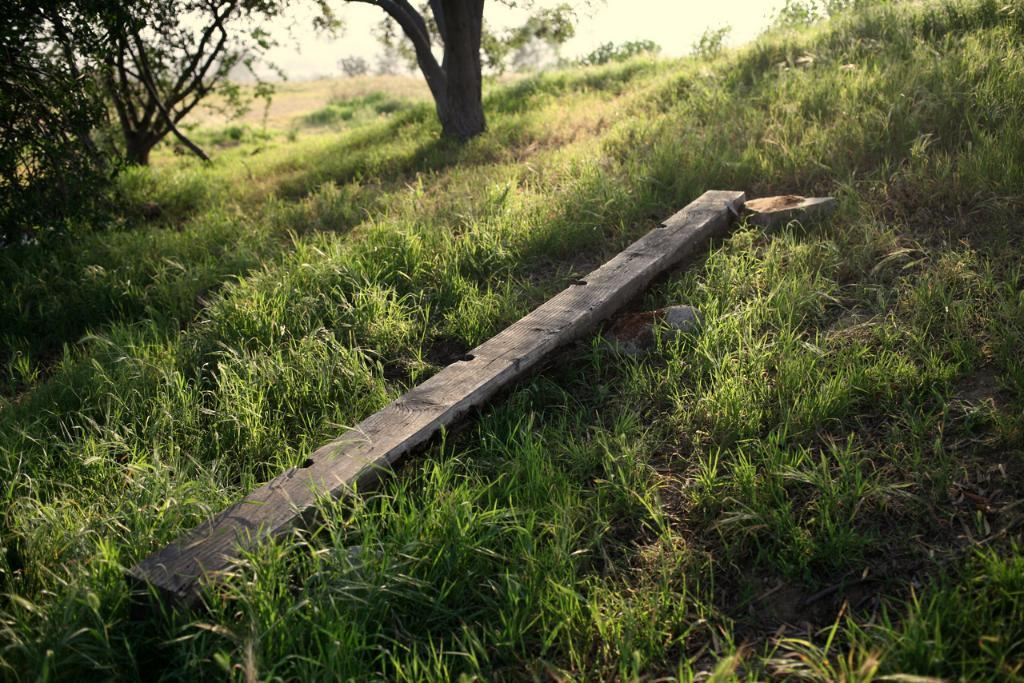What is on the ground in the image? There is a wooden pole and grass on the ground. What type of vegetation can be seen on the ground? There is grass on the ground. What can be seen in the background of the image? There are trees and plants in the background of the image. How much wealth is represented by the wooden pole in the image? The wooden pole does not represent any wealth; it is simply a wooden pole on the ground. Can you see any cows in the image? There are no cows present in the image. 